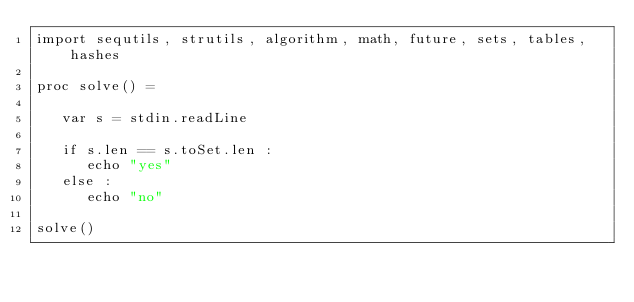Convert code to text. <code><loc_0><loc_0><loc_500><loc_500><_Nim_>import sequtils, strutils, algorithm, math, future, sets, tables, hashes

proc solve() =
   
   var s = stdin.readLine

   if s.len == s.toSet.len : 
      echo "yes"
   else : 
      echo "no"

solve()</code> 